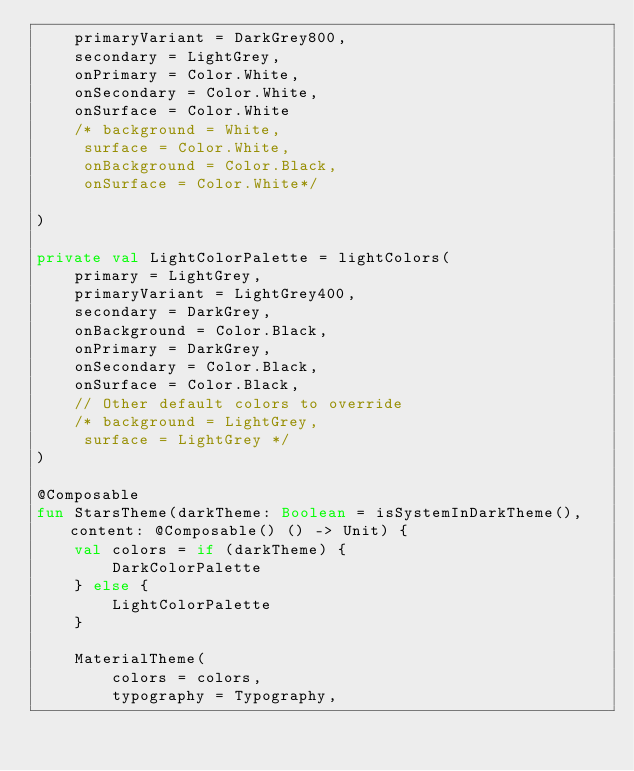<code> <loc_0><loc_0><loc_500><loc_500><_Kotlin_>    primaryVariant = DarkGrey800,
    secondary = LightGrey,
    onPrimary = Color.White,
    onSecondary = Color.White,
    onSurface = Color.White
    /* background = White,
     surface = Color.White,
     onBackground = Color.Black,
     onSurface = Color.White*/

)

private val LightColorPalette = lightColors(
    primary = LightGrey,
    primaryVariant = LightGrey400,
    secondary = DarkGrey,
    onBackground = Color.Black,
    onPrimary = DarkGrey,
    onSecondary = Color.Black,
    onSurface = Color.Black,
    // Other default colors to override
    /* background = LightGrey,
     surface = LightGrey */
)

@Composable
fun StarsTheme(darkTheme: Boolean = isSystemInDarkTheme(), content: @Composable() () -> Unit) {
    val colors = if (darkTheme) {
        DarkColorPalette
    } else {
        LightColorPalette
    }

    MaterialTheme(
        colors = colors,
        typography = Typography,</code> 